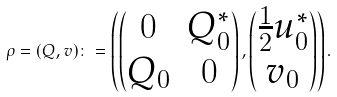<formula> <loc_0><loc_0><loc_500><loc_500>\rho = ( Q , v ) \colon = \left ( \begin{pmatrix} 0 & Q _ { 0 } ^ { \ast } \\ Q _ { 0 } & 0 \end{pmatrix} , \begin{pmatrix} \frac { 1 } { 2 } u _ { 0 } ^ { \ast } \\ v _ { 0 } \end{pmatrix} \right ) .</formula> 